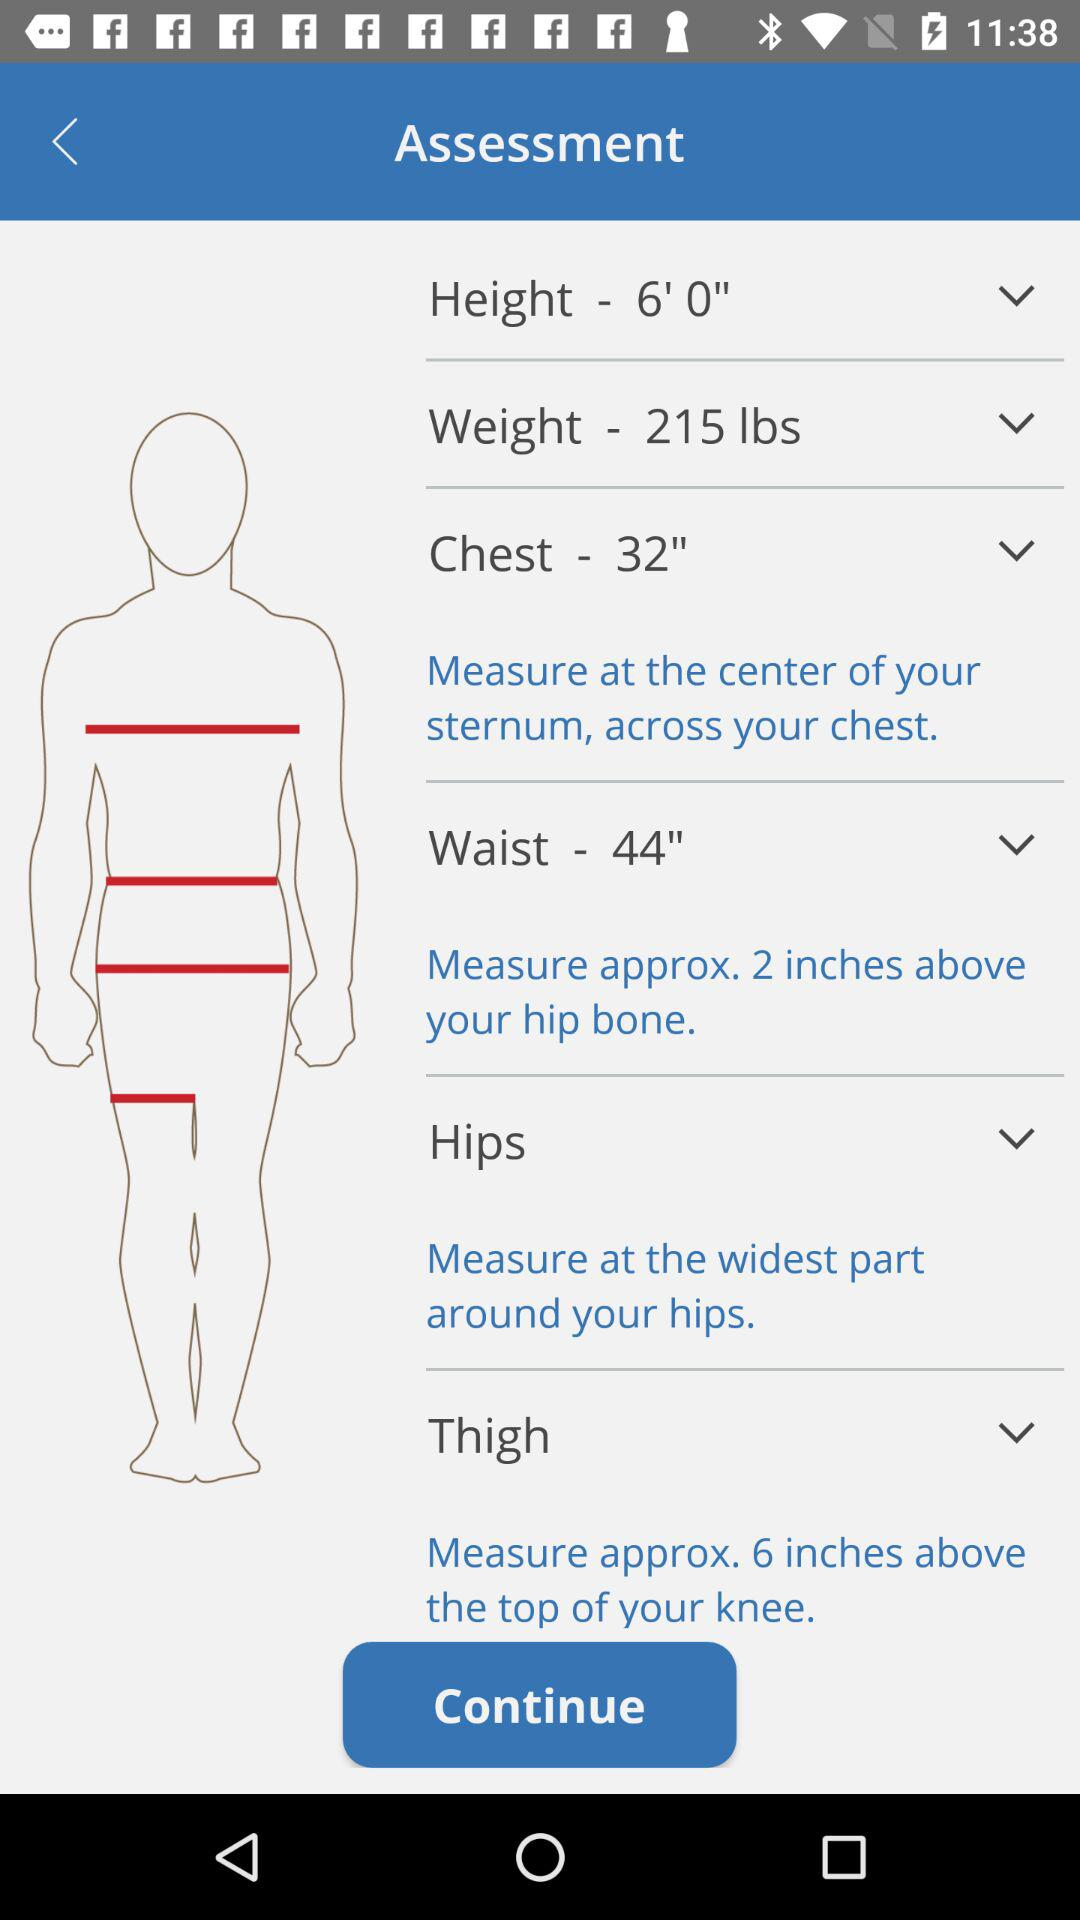What is the given chest size? The given chest size is 32 inches. 